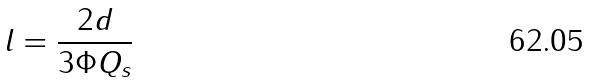Convert formula to latex. <formula><loc_0><loc_0><loc_500><loc_500>l = \frac { 2 d } { 3 \Phi Q _ { s } }</formula> 